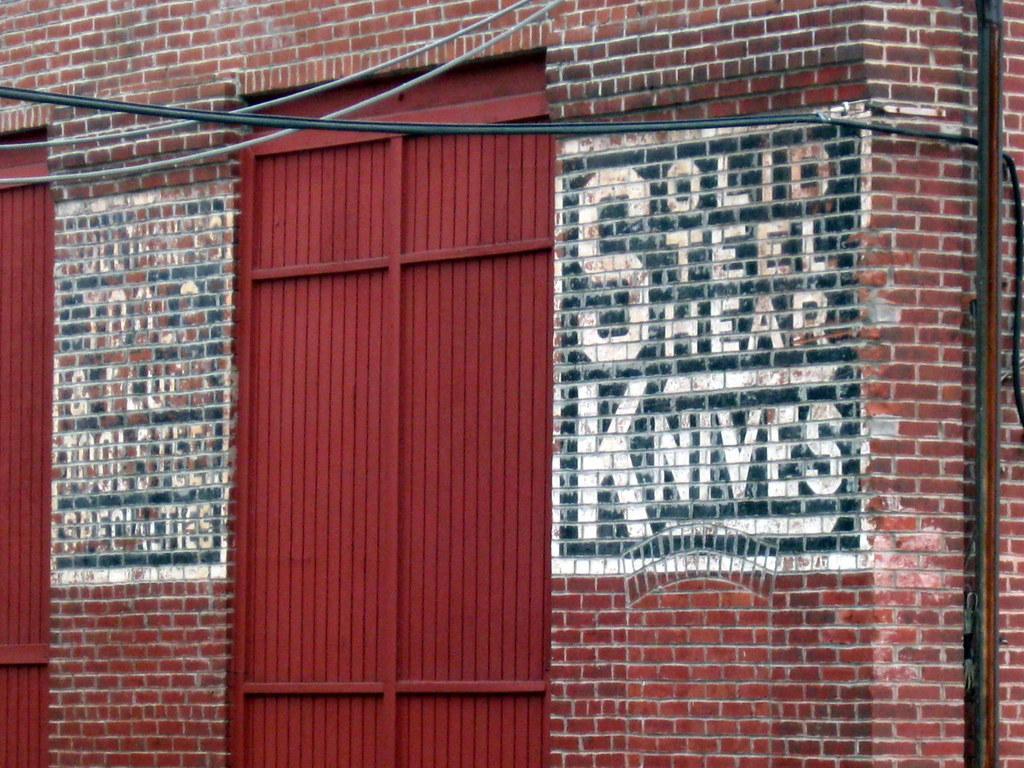Describe this image in one or two sentences. In this picture there is a construction made with black walls. In the center of the picture there is a gate. On the left there is another gate. At the top they are cables. On the right, there are pipes. 